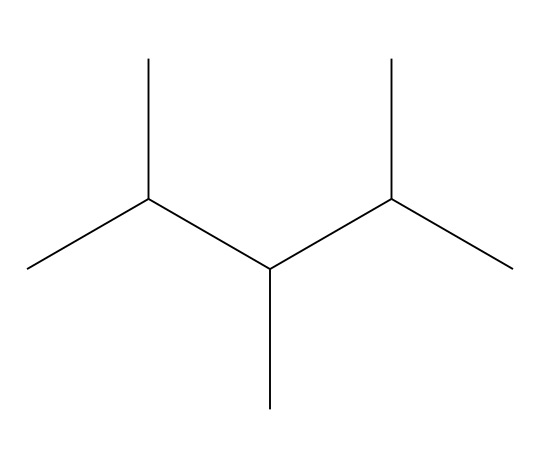What is the name of this chemical? The SMILES representation indicates a polymer known as polypropylene, which is a common plastic. The structure shown reflects its composition.
Answer: polypropylene How many carbon atoms are in this structure? The SMILES notation "CC(C)C(C)C(C)C" represents a total of 6 carbon atoms, counted by examining the chain and branches.
Answer: 6 What type of bonding is primarily present in this chemical? The structure shows single bonds between the carbon atoms, characteristic of saturated hydrocarbons like polypropylene, confirming it has covalent bonding.
Answer: covalent How is this chemical classified in terms of physical states? Given that the structure represents polypropylene, it is classified as a thermoplastic, as plastics typically exist in solid or semi-solid states at room temperature.
Answer: thermoplastic What property makes polypropylene suitable for veterinary syringes? The structure of polypropylene allows for flexibility and chemical resistance, which makes it ideal for medical applications like syringes.
Answer: flexibility How many hydrogen atoms are associated with the carbon atoms in this structure? Each carbon atom in this case is bonded to enough hydrogen atoms to saturate it, resulting in 12 hydrogen atoms for the 6 carbon atoms as per the general formula for alkanes (CnH2n+2).
Answer: 12 What is a significant environmental concern related to polypropylene? Polypropylene is a plastic, and a major environmental concern is its non-biodegradability, which contributes to plastic pollution.
Answer: non-biodegradability 